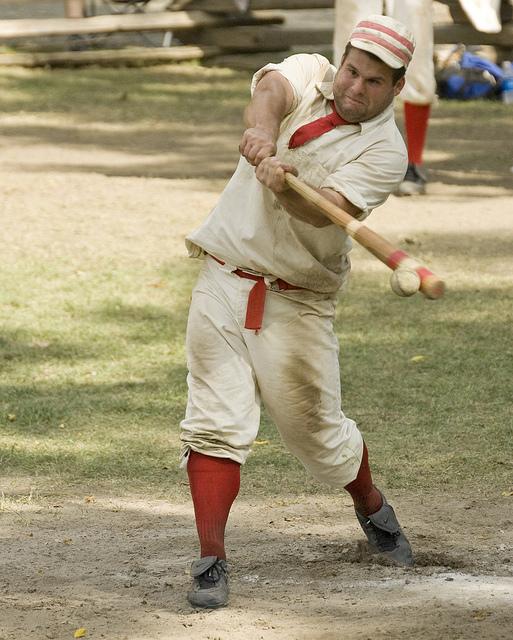How is the ground?
Answer briefly. Dry. Is this in the city?
Short answer required. Yes. What did the man just do?
Write a very short answer. Hit ball. Could this uniform be considered retro?
Answer briefly. Yes. How many hands does the man have?
Keep it brief. 2. What color is his socks?
Be succinct. Red. Do his socks match?
Answer briefly. Yes. What sport is he playing?
Short answer required. Baseball. 